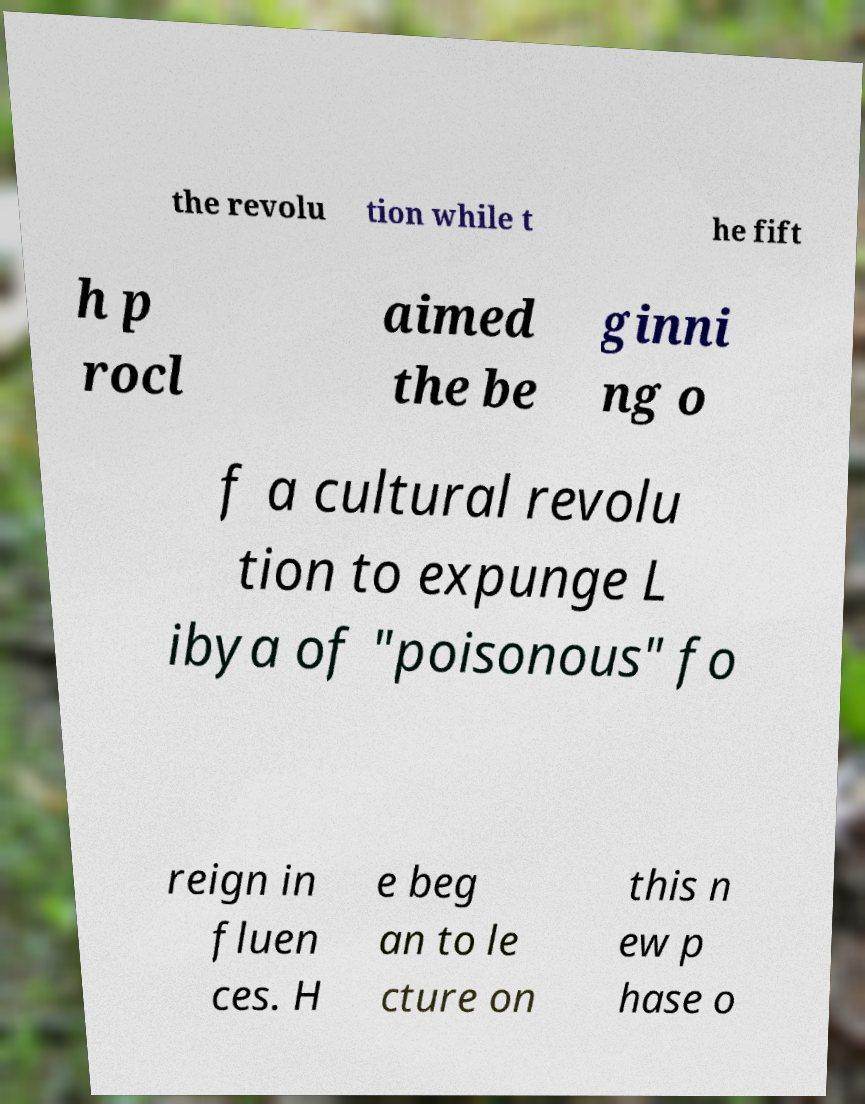Can you read and provide the text displayed in the image?This photo seems to have some interesting text. Can you extract and type it out for me? the revolu tion while t he fift h p rocl aimed the be ginni ng o f a cultural revolu tion to expunge L ibya of "poisonous" fo reign in fluen ces. H e beg an to le cture on this n ew p hase o 